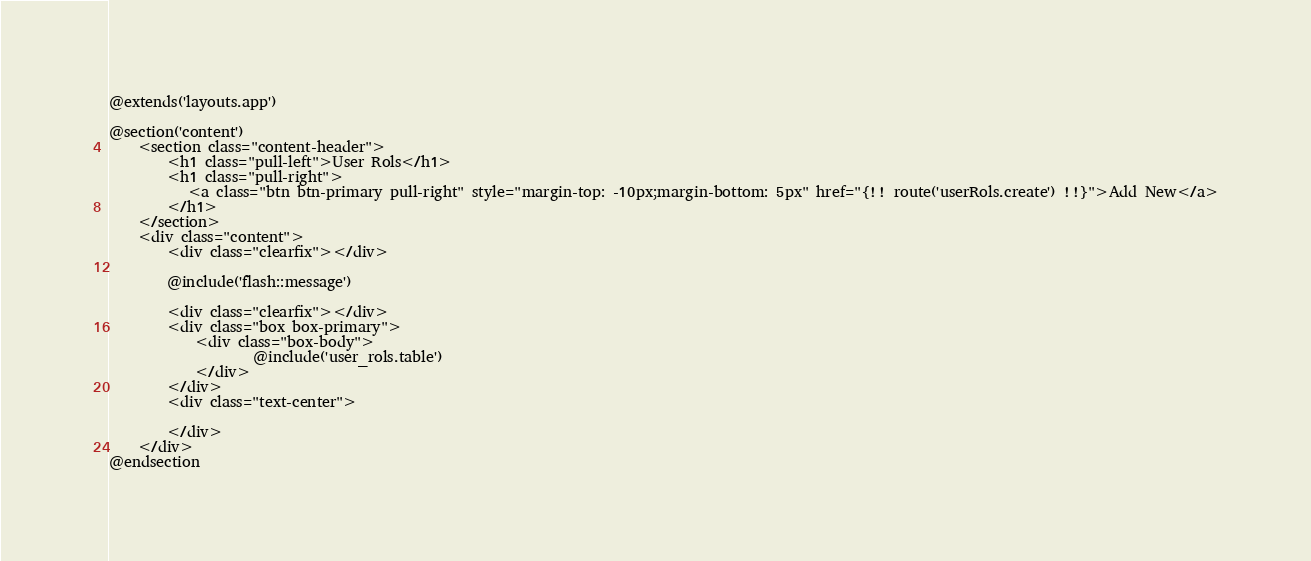Convert code to text. <code><loc_0><loc_0><loc_500><loc_500><_PHP_>@extends('layouts.app')

@section('content')
    <section class="content-header">
        <h1 class="pull-left">User Rols</h1>
        <h1 class="pull-right">
           <a class="btn btn-primary pull-right" style="margin-top: -10px;margin-bottom: 5px" href="{!! route('userRols.create') !!}">Add New</a>
        </h1>
    </section>
    <div class="content">
        <div class="clearfix"></div>

        @include('flash::message')

        <div class="clearfix"></div>
        <div class="box box-primary">
            <div class="box-body">
                    @include('user_rols.table')
            </div>
        </div>
        <div class="text-center">
        
        </div>
    </div>
@endsection

</code> 